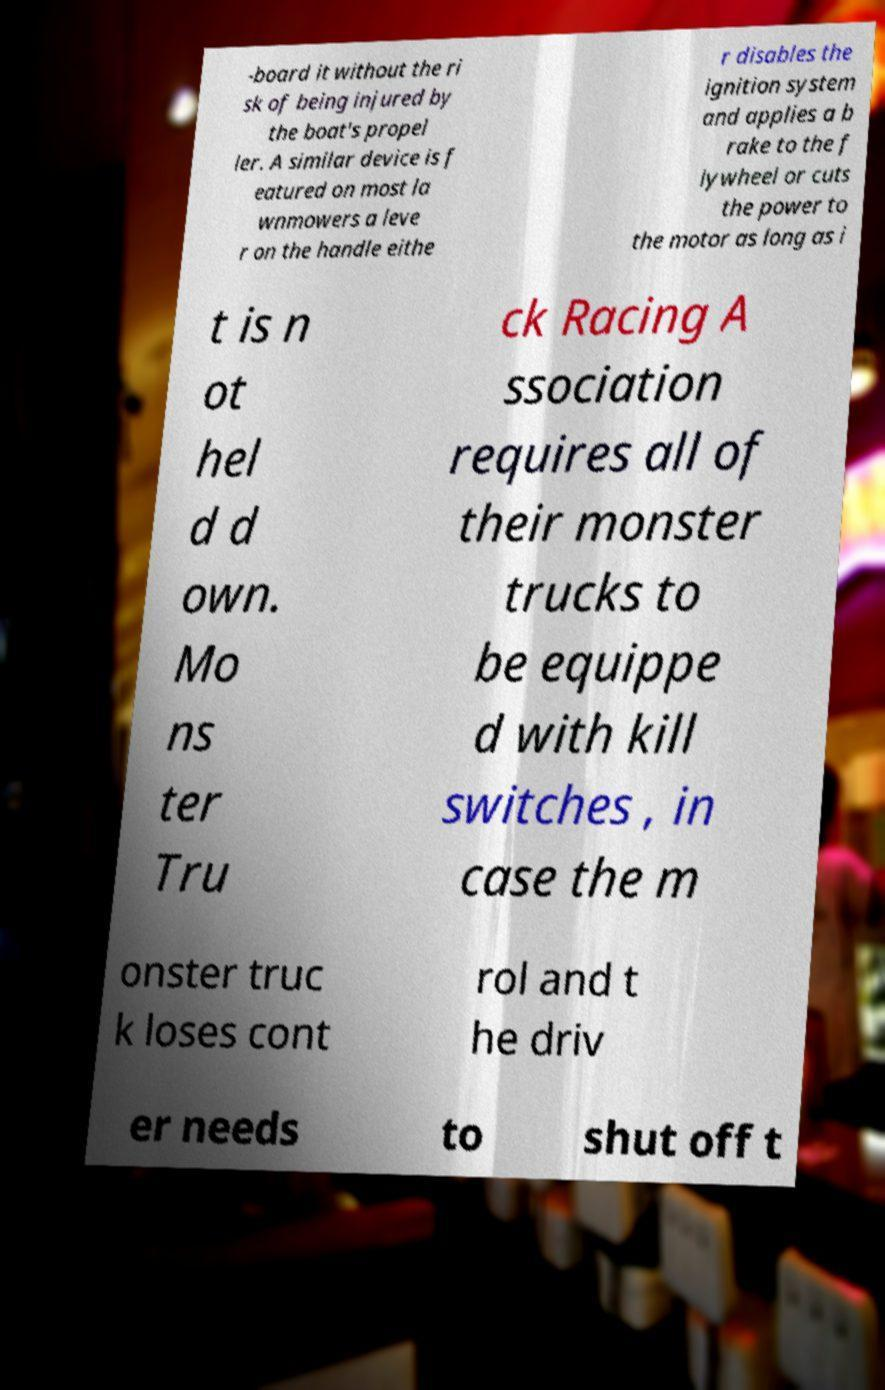Can you read and provide the text displayed in the image?This photo seems to have some interesting text. Can you extract and type it out for me? -board it without the ri sk of being injured by the boat's propel ler. A similar device is f eatured on most la wnmowers a leve r on the handle eithe r disables the ignition system and applies a b rake to the f lywheel or cuts the power to the motor as long as i t is n ot hel d d own. Mo ns ter Tru ck Racing A ssociation requires all of their monster trucks to be equippe d with kill switches , in case the m onster truc k loses cont rol and t he driv er needs to shut off t 